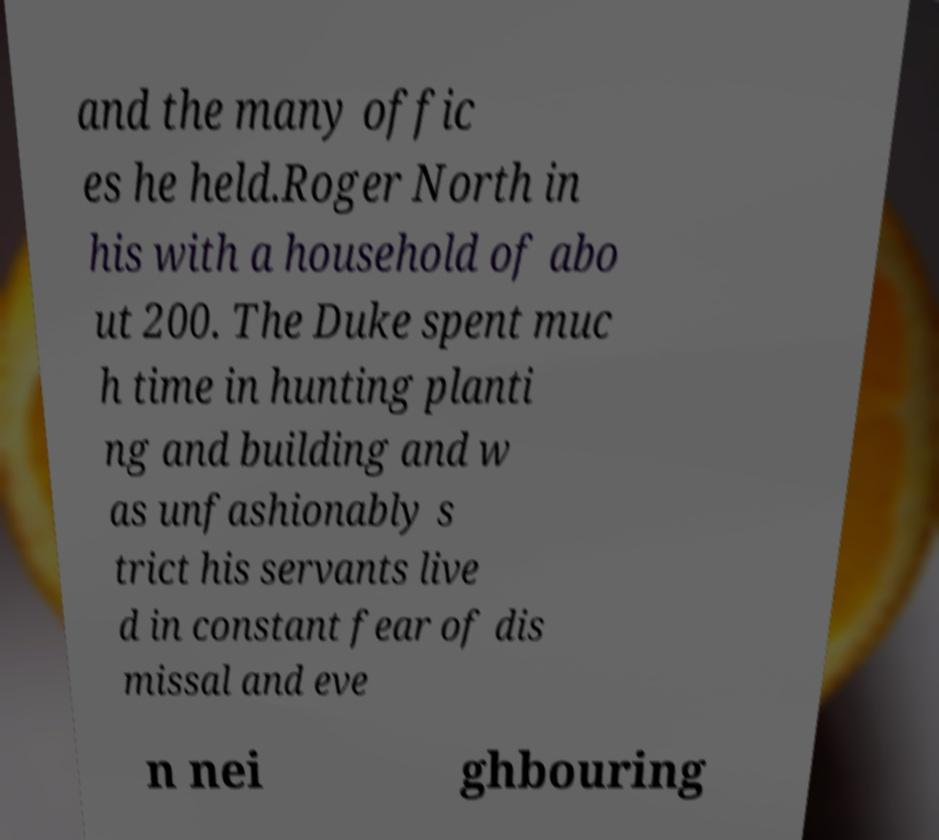Can you accurately transcribe the text from the provided image for me? and the many offic es he held.Roger North in his with a household of abo ut 200. The Duke spent muc h time in hunting planti ng and building and w as unfashionably s trict his servants live d in constant fear of dis missal and eve n nei ghbouring 